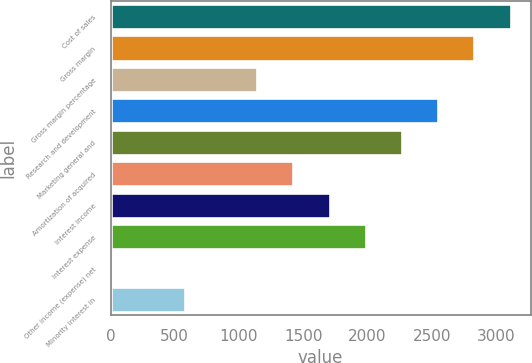Convert chart to OTSL. <chart><loc_0><loc_0><loc_500><loc_500><bar_chart><fcel>Cost of sales<fcel>Gross margin<fcel>Gross margin percentage<fcel>Research and development<fcel>Marketing general and<fcel>Amortization of acquired<fcel>Interest income<fcel>Interest expense<fcel>Other income (expense) net<fcel>Minority interest in<nl><fcel>3115<fcel>2833<fcel>1141<fcel>2551<fcel>2269<fcel>1423<fcel>1705<fcel>1987<fcel>13<fcel>577<nl></chart> 